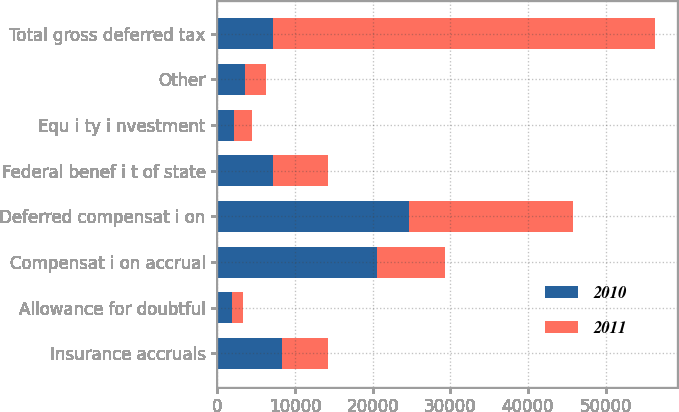<chart> <loc_0><loc_0><loc_500><loc_500><stacked_bar_chart><ecel><fcel>Insurance accruals<fcel>Allowance for doubtful<fcel>Compensat i on accrual<fcel>Deferred compensat i on<fcel>Federal benef i t of state<fcel>Equ i ty i nvestment<fcel>Other<fcel>Total gross deferred tax<nl><fcel>2010<fcel>8316<fcel>1827<fcel>20522<fcel>24727<fcel>7155<fcel>2197<fcel>3584<fcel>7116<nl><fcel>2011<fcel>5892<fcel>1462<fcel>8814<fcel>21072<fcel>7116<fcel>2197<fcel>2685<fcel>49238<nl></chart> 